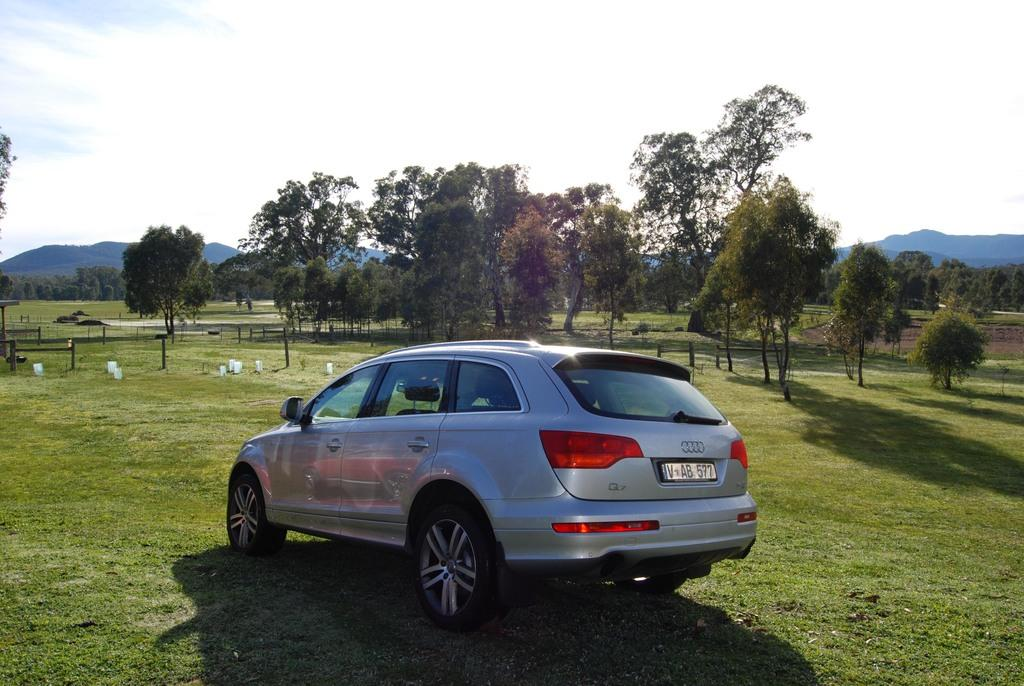What is the main subject of the image? There is a car in the image. Where is the car located? The car is on the grass. What can be seen in front of the car? There are objects in front of the car. What type of natural environment is visible in the image? There are trees and hills in the image. What is visible in the background of the image? The sky is visible in the image. How many eyes does the car have in the image? Cars do not have eyes, so this question cannot be answered. Can you see a hen in the image? There is no hen present in the image. 